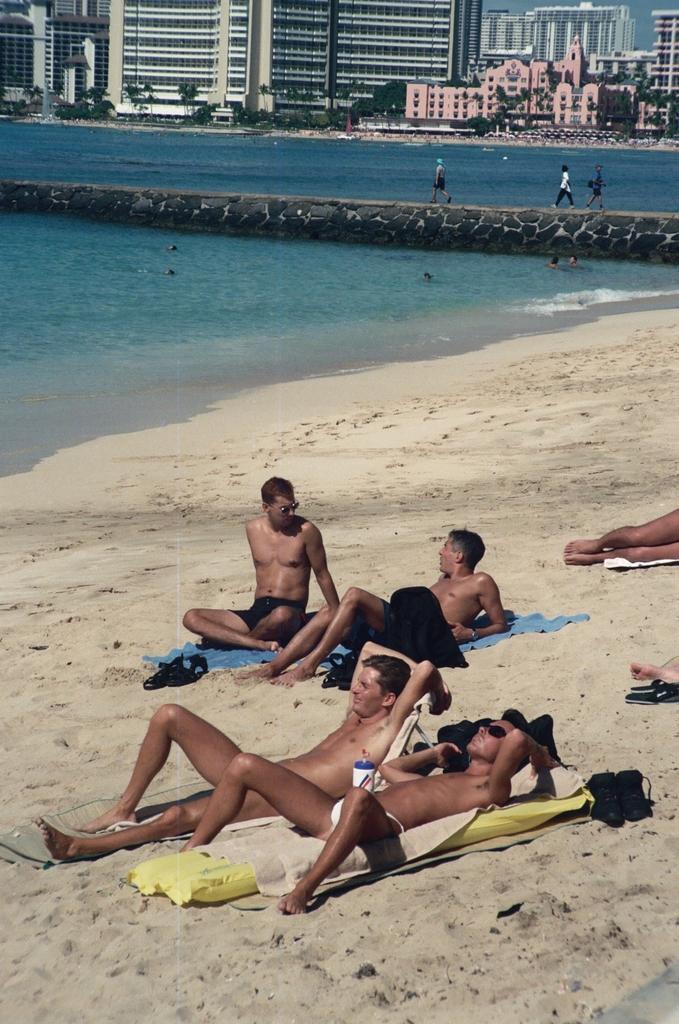In one or two sentences, can you explain what this image depicts? In this image I can see group of people some are sitting and some are laying on the sand. Background I can see water, trees in green color, few buildings in white, cream and pink color, and the sky is in blue color. 